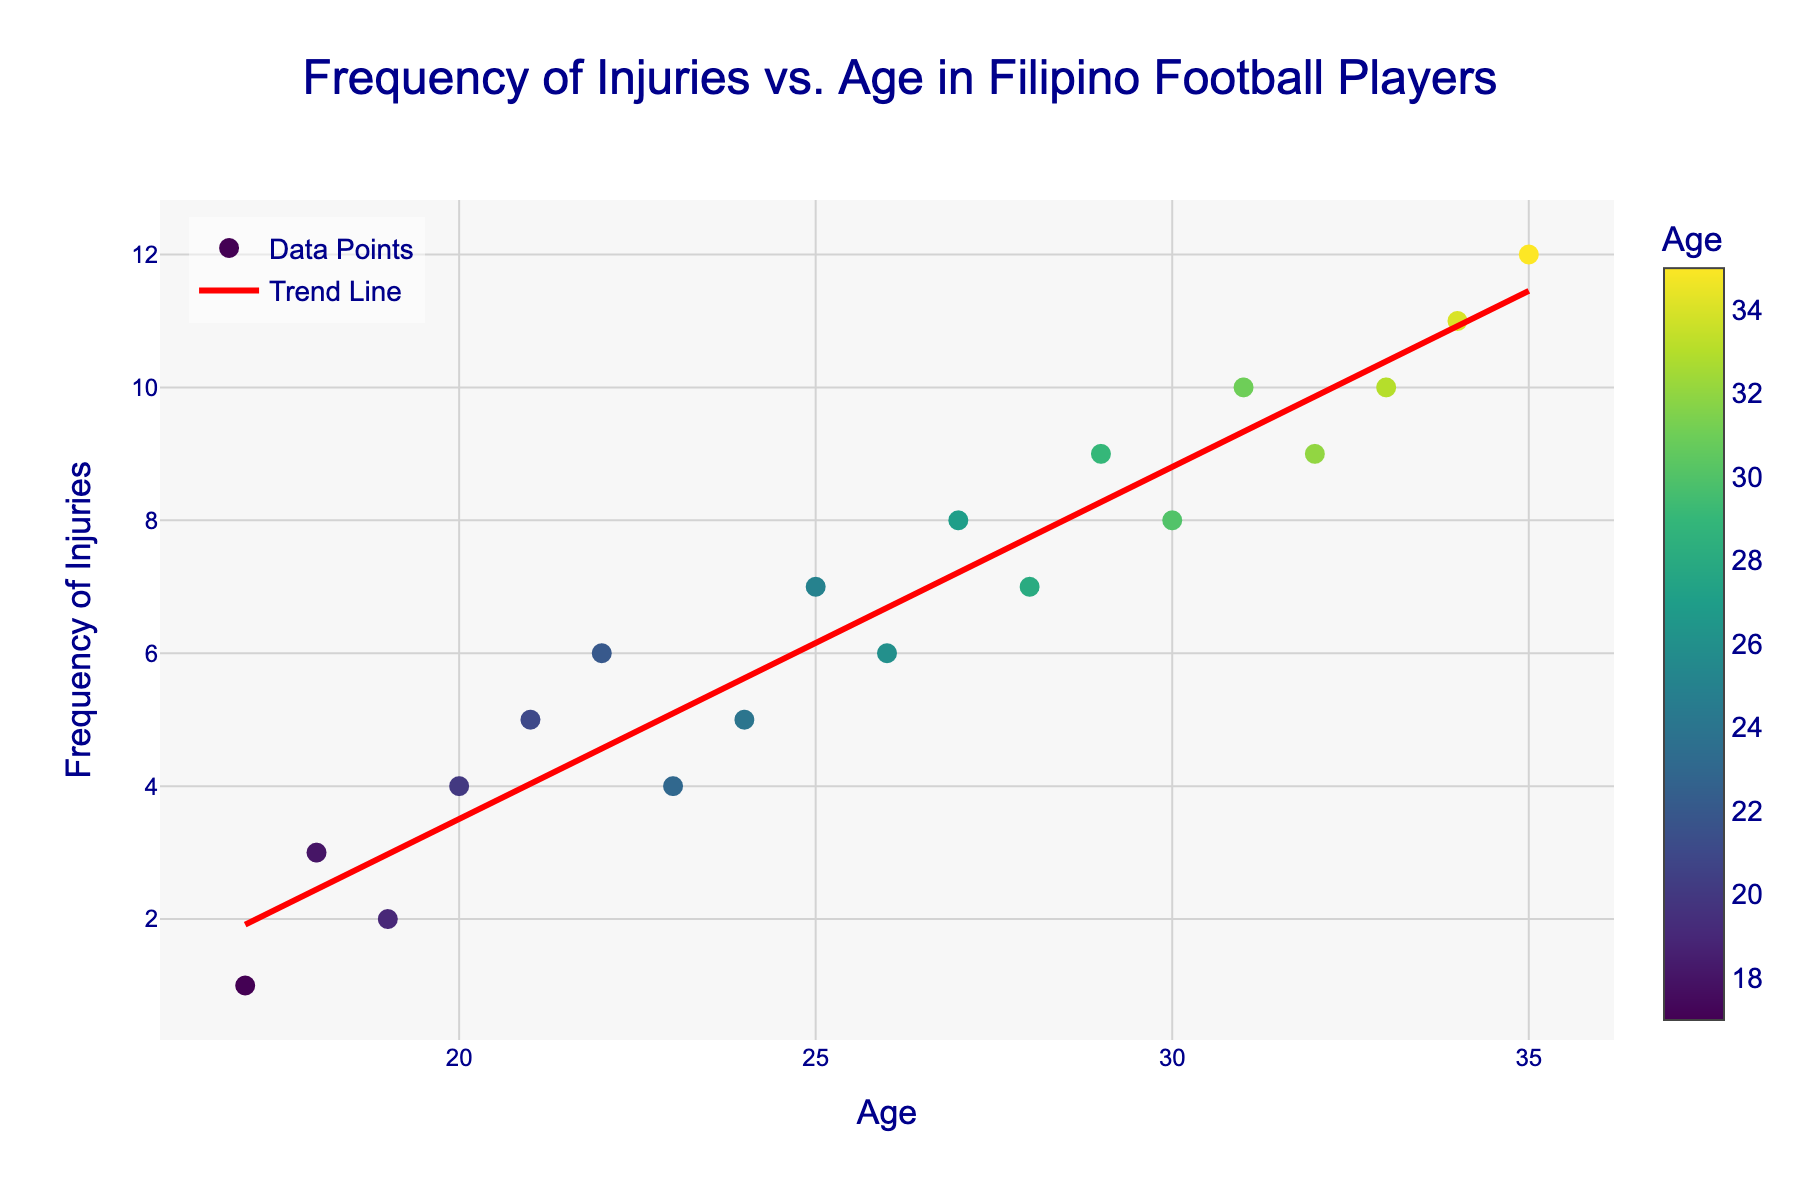What is the title of the figure? The title is displayed at the top center of the figure. It reads "Frequency of Injuries vs. Age in Filipino Football Players".
Answer: Frequency of Injuries vs. Age in Filipino Football Players How many data points are represented in the scatter plot? Each data point corresponds to a combination of age and frequency of injuries, and there are 19 such points from ages 17 to 35.
Answer: 19 What is the color of the trend line? The trend line in the figure is visually distinct and colored red.
Answer: Red What is the general trend observed in the frequency of injuries as age increases? The trend line indicates an increasing pattern, meaning the frequency of injuries tends to rise as age increases.
Answer: Increasing At what age does the frequency of injuries first reach 10? By looking at the scatter plot, we'll notice that the frequency of injuries reaches 10 at ages 31 and 33. The earliest occurrence is at age 31.
Answer: 31 How many ages have a frequency of injuries greater than or equal to 10? From the scatter plot, we see that the ages with frequencies of 10 or higher are 31, 33, 34, and 35. Counting these instances gives us four ages.
Answer: 4 What is the range of the x-axis and y-axis? The x-axis represents age and ranges from 17 to 35. The y-axis represents frequency of injuries and ranges from 0 to 12.
Answer: x-axis: 17-35, y-axis: 0-12 Is there an age with a frequency of injuries equal to 6? If so, what is it? By examining the scatter plot, we can see that age 22 and age 26 both have a frequency of injuries equal to 6.
Answer: Yes, 22 and 26 What is the difference in the frequency of injuries between the ages of 20 and 25? The frequency of injuries at age 20 is 4, and at age 25 is 7. The difference between them is 7 - 4 = 3.
Answer: 3 What is the median frequency of injuries for ages between 20 and 30? The ages between 20 and 30 (inclusive) are 20, 21, 22, 23, 24, 25, 26, 27, 28, 29, and 30. The corresponding frequencies are 4, 5, 6, 4, 5, 7, 6, 8, 7, 9, and 8. Arranging them in order: 4, 4, 5, 5, 6, 6, 7, 7, 8, 8, 9. The median is the middle value: 6.
Answer: 6 